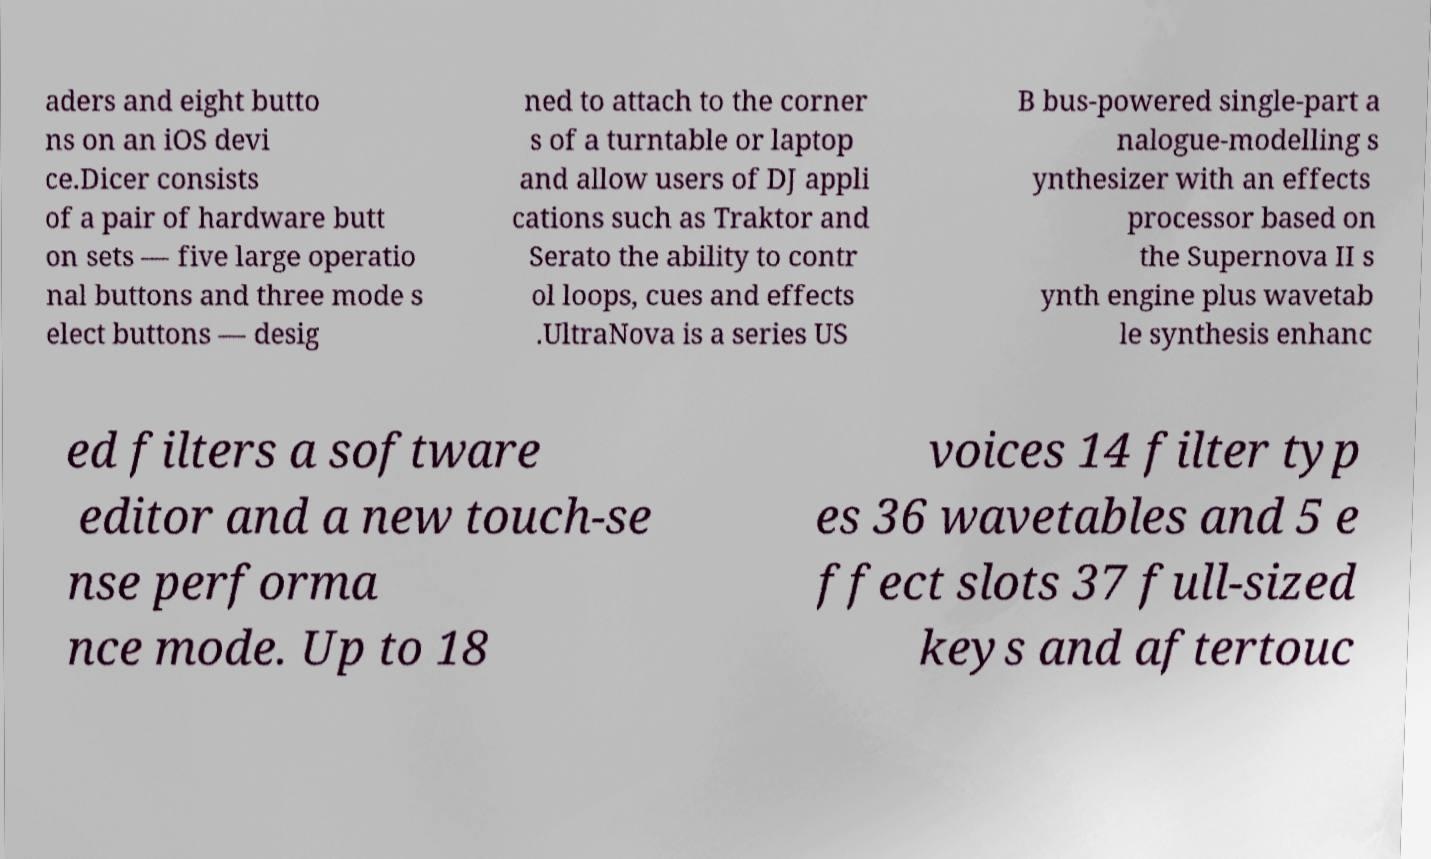What messages or text are displayed in this image? I need them in a readable, typed format. aders and eight butto ns on an iOS devi ce.Dicer consists of a pair of hardware butt on sets — five large operatio nal buttons and three mode s elect buttons — desig ned to attach to the corner s of a turntable or laptop and allow users of DJ appli cations such as Traktor and Serato the ability to contr ol loops, cues and effects .UltraNova is a series US B bus-powered single-part a nalogue-modelling s ynthesizer with an effects processor based on the Supernova II s ynth engine plus wavetab le synthesis enhanc ed filters a software editor and a new touch-se nse performa nce mode. Up to 18 voices 14 filter typ es 36 wavetables and 5 e ffect slots 37 full-sized keys and aftertouc 